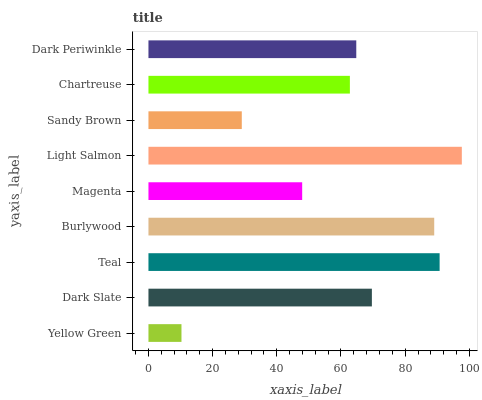Is Yellow Green the minimum?
Answer yes or no. Yes. Is Light Salmon the maximum?
Answer yes or no. Yes. Is Dark Slate the minimum?
Answer yes or no. No. Is Dark Slate the maximum?
Answer yes or no. No. Is Dark Slate greater than Yellow Green?
Answer yes or no. Yes. Is Yellow Green less than Dark Slate?
Answer yes or no. Yes. Is Yellow Green greater than Dark Slate?
Answer yes or no. No. Is Dark Slate less than Yellow Green?
Answer yes or no. No. Is Dark Periwinkle the high median?
Answer yes or no. Yes. Is Dark Periwinkle the low median?
Answer yes or no. Yes. Is Dark Slate the high median?
Answer yes or no. No. Is Magenta the low median?
Answer yes or no. No. 